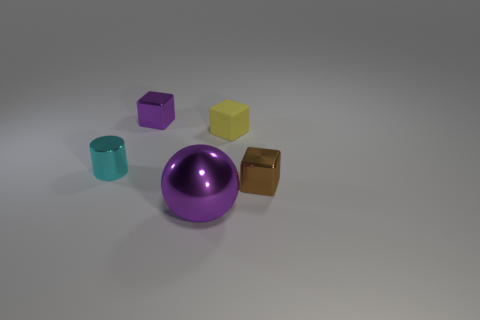How would the lighting in the scene affect the appearance of these objects in a real-world setting? In a real-world setting, the lighting would play a crucial role in the appearance of these objects. Their reflective surfaces would cast highlights and variable shadows, altering their perceived colors and textures. The sphere, in particular, would likely cast a softer shadow and showcase more pronounced highlights due to its curved surface. 